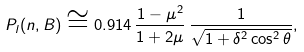<formula> <loc_0><loc_0><loc_500><loc_500>P _ { l } ( { n } , { B } ) \cong 0 . 9 1 4 \, \frac { 1 - \mu ^ { 2 } } { 1 + 2 \mu } \, \frac { 1 } { \sqrt { 1 + \delta ^ { 2 } \cos ^ { 2 } \theta } } ,</formula> 